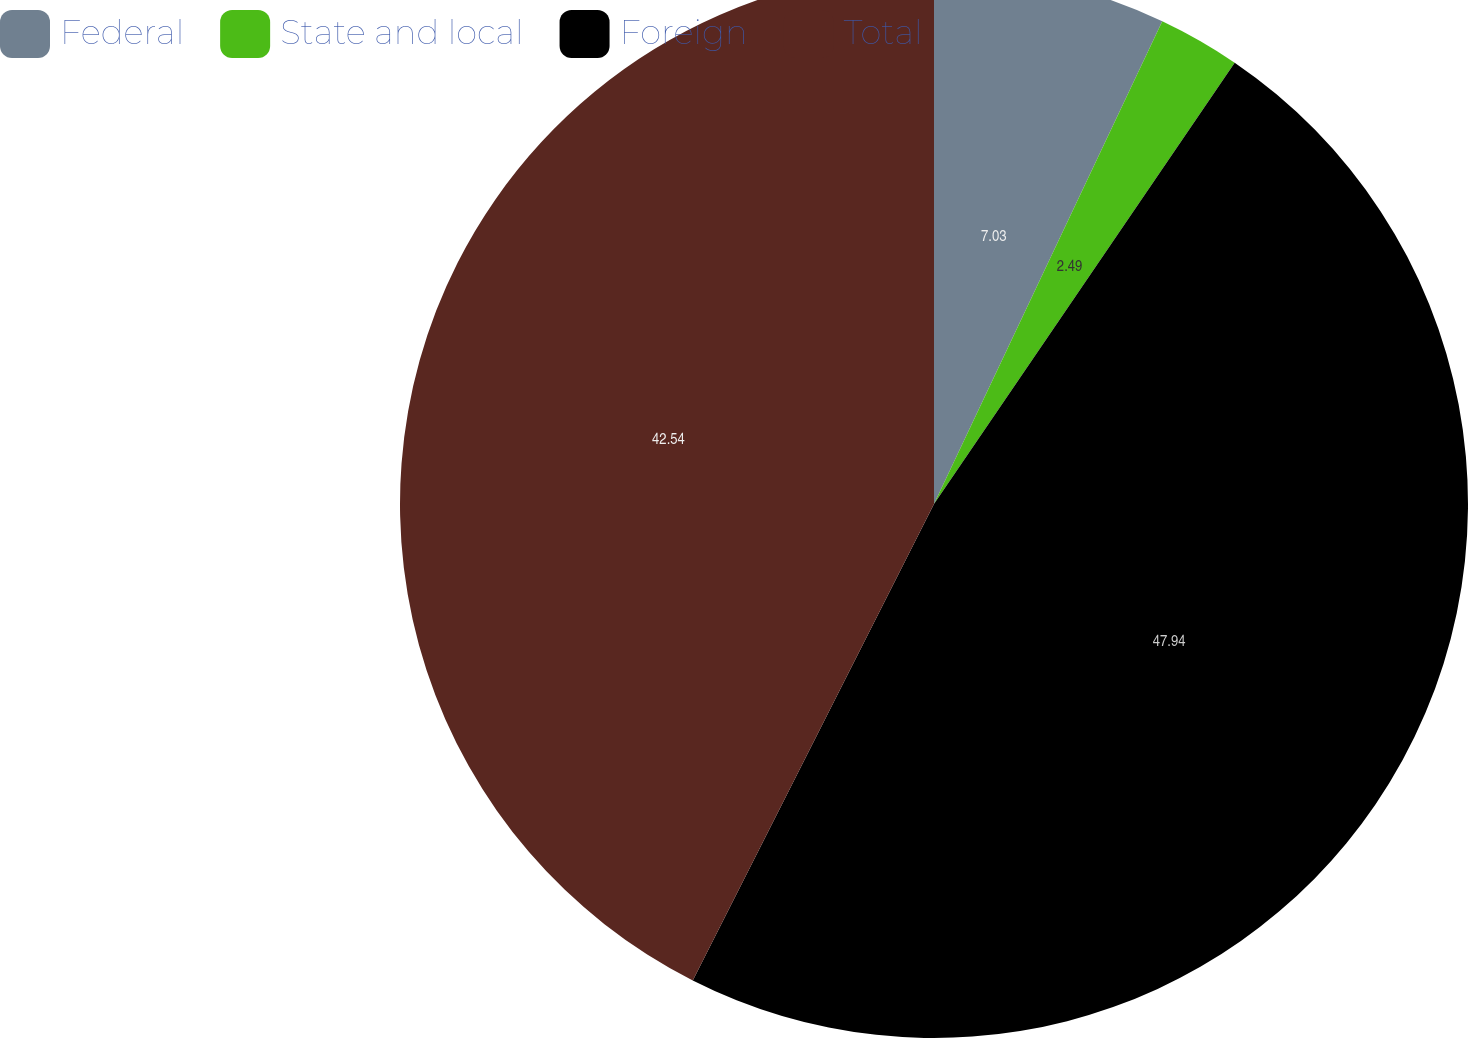<chart> <loc_0><loc_0><loc_500><loc_500><pie_chart><fcel>Federal<fcel>State and local<fcel>Foreign<fcel>Total<nl><fcel>7.03%<fcel>2.49%<fcel>47.94%<fcel>42.54%<nl></chart> 